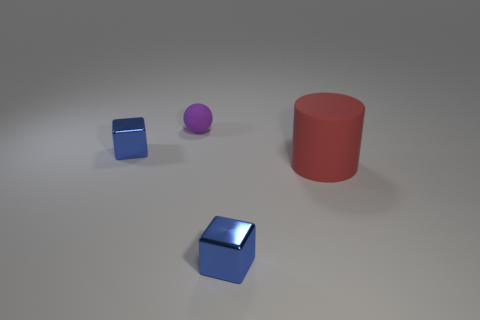Add 4 tiny matte things. How many objects exist? 8 Subtract 1 cylinders. How many cylinders are left? 0 Subtract all cylinders. How many objects are left? 3 Subtract all green rubber objects. Subtract all cubes. How many objects are left? 2 Add 1 small purple matte balls. How many small purple matte balls are left? 2 Add 2 purple matte balls. How many purple matte balls exist? 3 Subtract 0 gray blocks. How many objects are left? 4 Subtract all red cubes. Subtract all yellow cylinders. How many cubes are left? 2 